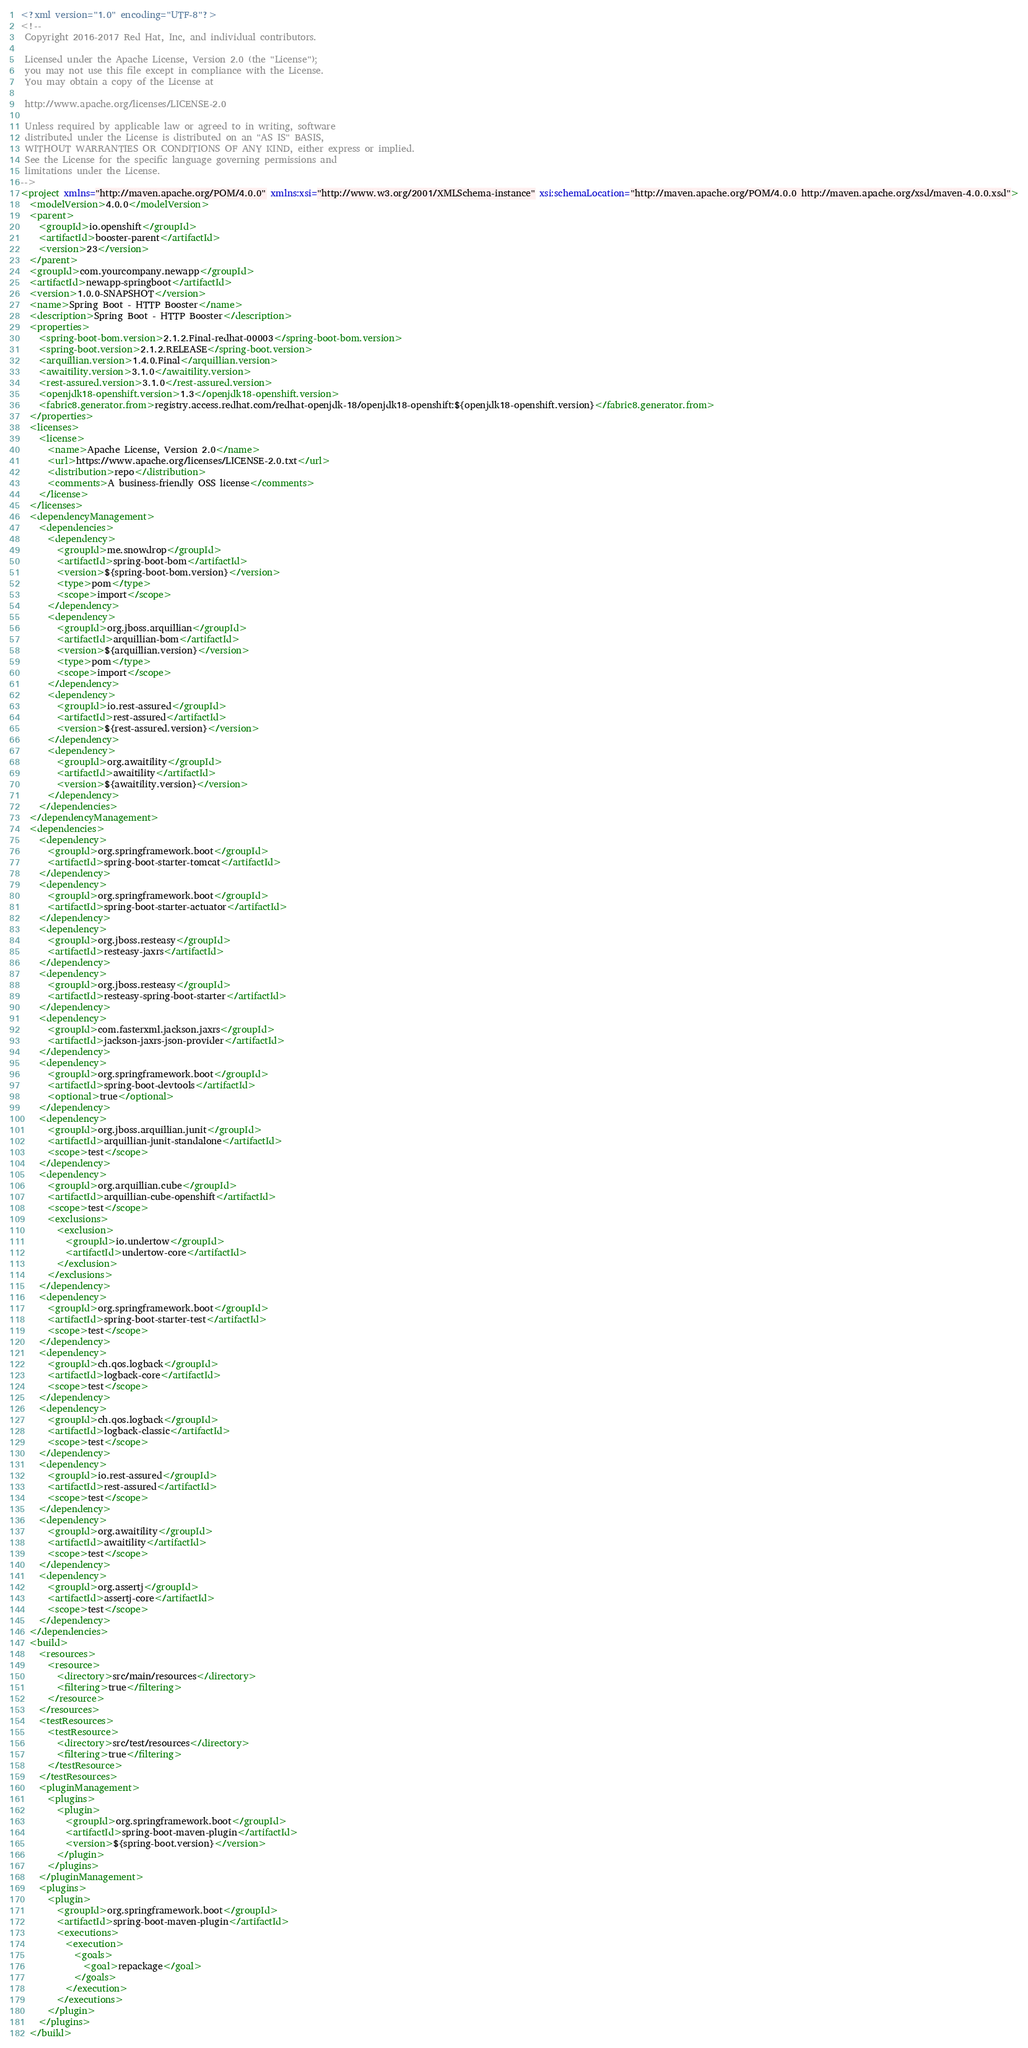<code> <loc_0><loc_0><loc_500><loc_500><_XML_><?xml version="1.0" encoding="UTF-8"?>
<!--
 Copyright 2016-2017 Red Hat, Inc, and individual contributors.

 Licensed under the Apache License, Version 2.0 (the "License");
 you may not use this file except in compliance with the License.
 You may obtain a copy of the License at

 http://www.apache.org/licenses/LICENSE-2.0

 Unless required by applicable law or agreed to in writing, software
 distributed under the License is distributed on an "AS IS" BASIS,
 WITHOUT WARRANTIES OR CONDITIONS OF ANY KIND, either express or implied.
 See the License for the specific language governing permissions and
 limitations under the License.
-->
<project xmlns="http://maven.apache.org/POM/4.0.0" xmlns:xsi="http://www.w3.org/2001/XMLSchema-instance" xsi:schemaLocation="http://maven.apache.org/POM/4.0.0 http://maven.apache.org/xsd/maven-4.0.0.xsd">
  <modelVersion>4.0.0</modelVersion>
  <parent>
    <groupId>io.openshift</groupId>
    <artifactId>booster-parent</artifactId>
    <version>23</version>
  </parent>
  <groupId>com.yourcompany.newapp</groupId>
  <artifactId>newapp-springboot</artifactId>
  <version>1.0.0-SNAPSHOT</version>
  <name>Spring Boot - HTTP Booster</name>
  <description>Spring Boot - HTTP Booster</description>
  <properties>
    <spring-boot-bom.version>2.1.2.Final-redhat-00003</spring-boot-bom.version>
    <spring-boot.version>2.1.2.RELEASE</spring-boot.version>
    <arquillian.version>1.4.0.Final</arquillian.version>
    <awaitility.version>3.1.0</awaitility.version>
    <rest-assured.version>3.1.0</rest-assured.version>
    <openjdk18-openshift.version>1.3</openjdk18-openshift.version>
    <fabric8.generator.from>registry.access.redhat.com/redhat-openjdk-18/openjdk18-openshift:${openjdk18-openshift.version}</fabric8.generator.from>
  </properties>
  <licenses>
    <license>
      <name>Apache License, Version 2.0</name>
      <url>https://www.apache.org/licenses/LICENSE-2.0.txt</url>
      <distribution>repo</distribution>
      <comments>A business-friendly OSS license</comments>
    </license>
  </licenses>
  <dependencyManagement>
    <dependencies>
      <dependency>
        <groupId>me.snowdrop</groupId>
        <artifactId>spring-boot-bom</artifactId>
        <version>${spring-boot-bom.version}</version>
        <type>pom</type>
        <scope>import</scope>
      </dependency>
      <dependency>
        <groupId>org.jboss.arquillian</groupId>
        <artifactId>arquillian-bom</artifactId>
        <version>${arquillian.version}</version>
        <type>pom</type>
        <scope>import</scope>
      </dependency>
      <dependency>
        <groupId>io.rest-assured</groupId>
        <artifactId>rest-assured</artifactId>
        <version>${rest-assured.version}</version>
      </dependency>
      <dependency>
        <groupId>org.awaitility</groupId>
        <artifactId>awaitility</artifactId>
        <version>${awaitility.version}</version>
      </dependency>
    </dependencies>
  </dependencyManagement>
  <dependencies>
    <dependency>
      <groupId>org.springframework.boot</groupId>
      <artifactId>spring-boot-starter-tomcat</artifactId>
    </dependency>
    <dependency>
      <groupId>org.springframework.boot</groupId>
      <artifactId>spring-boot-starter-actuator</artifactId>
    </dependency>
    <dependency>
      <groupId>org.jboss.resteasy</groupId>
      <artifactId>resteasy-jaxrs</artifactId>
    </dependency>
    <dependency>
      <groupId>org.jboss.resteasy</groupId>
      <artifactId>resteasy-spring-boot-starter</artifactId>
    </dependency>
    <dependency>
      <groupId>com.fasterxml.jackson.jaxrs</groupId>
      <artifactId>jackson-jaxrs-json-provider</artifactId>
    </dependency>
    <dependency>
      <groupId>org.springframework.boot</groupId>
      <artifactId>spring-boot-devtools</artifactId>
      <optional>true</optional>
    </dependency>
    <dependency>
      <groupId>org.jboss.arquillian.junit</groupId>
      <artifactId>arquillian-junit-standalone</artifactId>
      <scope>test</scope>
    </dependency>
    <dependency>
      <groupId>org.arquillian.cube</groupId>
      <artifactId>arquillian-cube-openshift</artifactId>
      <scope>test</scope>
      <exclusions>
        <exclusion>
          <groupId>io.undertow</groupId>
          <artifactId>undertow-core</artifactId>
        </exclusion>
      </exclusions>
    </dependency>
    <dependency>
      <groupId>org.springframework.boot</groupId>
      <artifactId>spring-boot-starter-test</artifactId>
      <scope>test</scope>
    </dependency>
    <dependency>
      <groupId>ch.qos.logback</groupId>
      <artifactId>logback-core</artifactId>
      <scope>test</scope>
    </dependency>
    <dependency>
      <groupId>ch.qos.logback</groupId>
      <artifactId>logback-classic</artifactId>
      <scope>test</scope>
    </dependency>
    <dependency>
      <groupId>io.rest-assured</groupId>
      <artifactId>rest-assured</artifactId>
      <scope>test</scope>
    </dependency>
    <dependency>
      <groupId>org.awaitility</groupId>
      <artifactId>awaitility</artifactId>
      <scope>test</scope>
    </dependency>
    <dependency>
      <groupId>org.assertj</groupId>
      <artifactId>assertj-core</artifactId>
      <scope>test</scope>
    </dependency>
  </dependencies>
  <build>
    <resources>
      <resource>
        <directory>src/main/resources</directory>
        <filtering>true</filtering>
      </resource>
    </resources>
    <testResources>
      <testResource>
        <directory>src/test/resources</directory>
        <filtering>true</filtering>
      </testResource>
    </testResources>
    <pluginManagement>
      <plugins>
        <plugin>
          <groupId>org.springframework.boot</groupId>
          <artifactId>spring-boot-maven-plugin</artifactId>
          <version>${spring-boot.version}</version>
        </plugin>
      </plugins>
    </pluginManagement>
    <plugins>
      <plugin>
        <groupId>org.springframework.boot</groupId>
        <artifactId>spring-boot-maven-plugin</artifactId>
        <executions>
          <execution>
            <goals>
              <goal>repackage</goal>
            </goals>
          </execution>
        </executions>
      </plugin>
    </plugins>
  </build></code> 